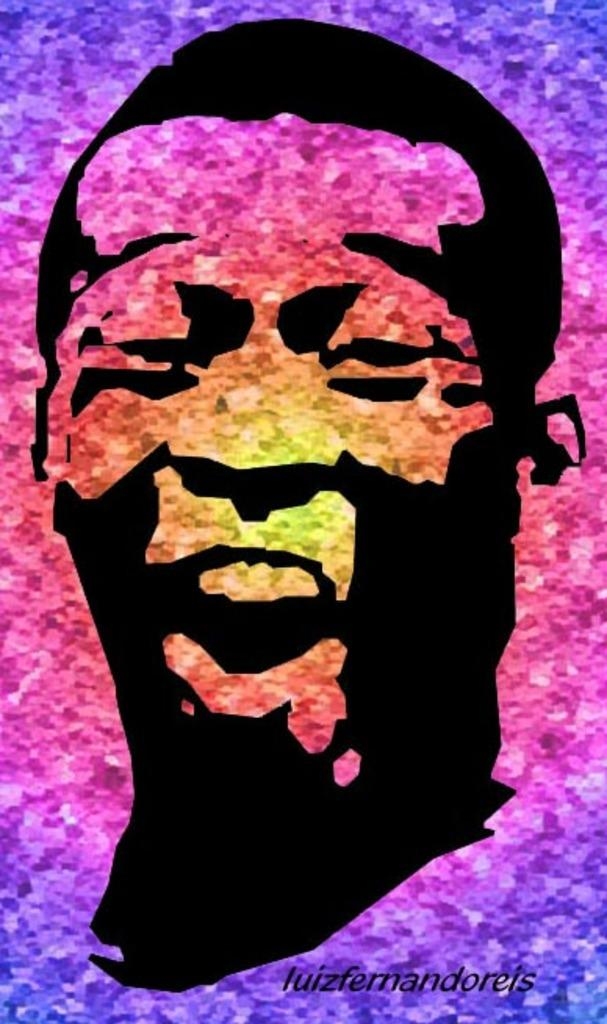What type of image is being described? The image is an edited picture. What is the main subject of the image? There is a picture of a person in the image. Is there any text present in the image? Yes, there is text at the bottom of the image. How many chickens are visible in the image? There are no chickens present in the image. What type of notebook is being used by the person in the image? There is no notebook visible in the image. 